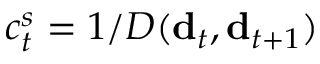Convert formula to latex. <formula><loc_0><loc_0><loc_500><loc_500>c _ { t } ^ { s } = 1 / D ( { d } _ { t } , { d } _ { t + 1 } )</formula> 